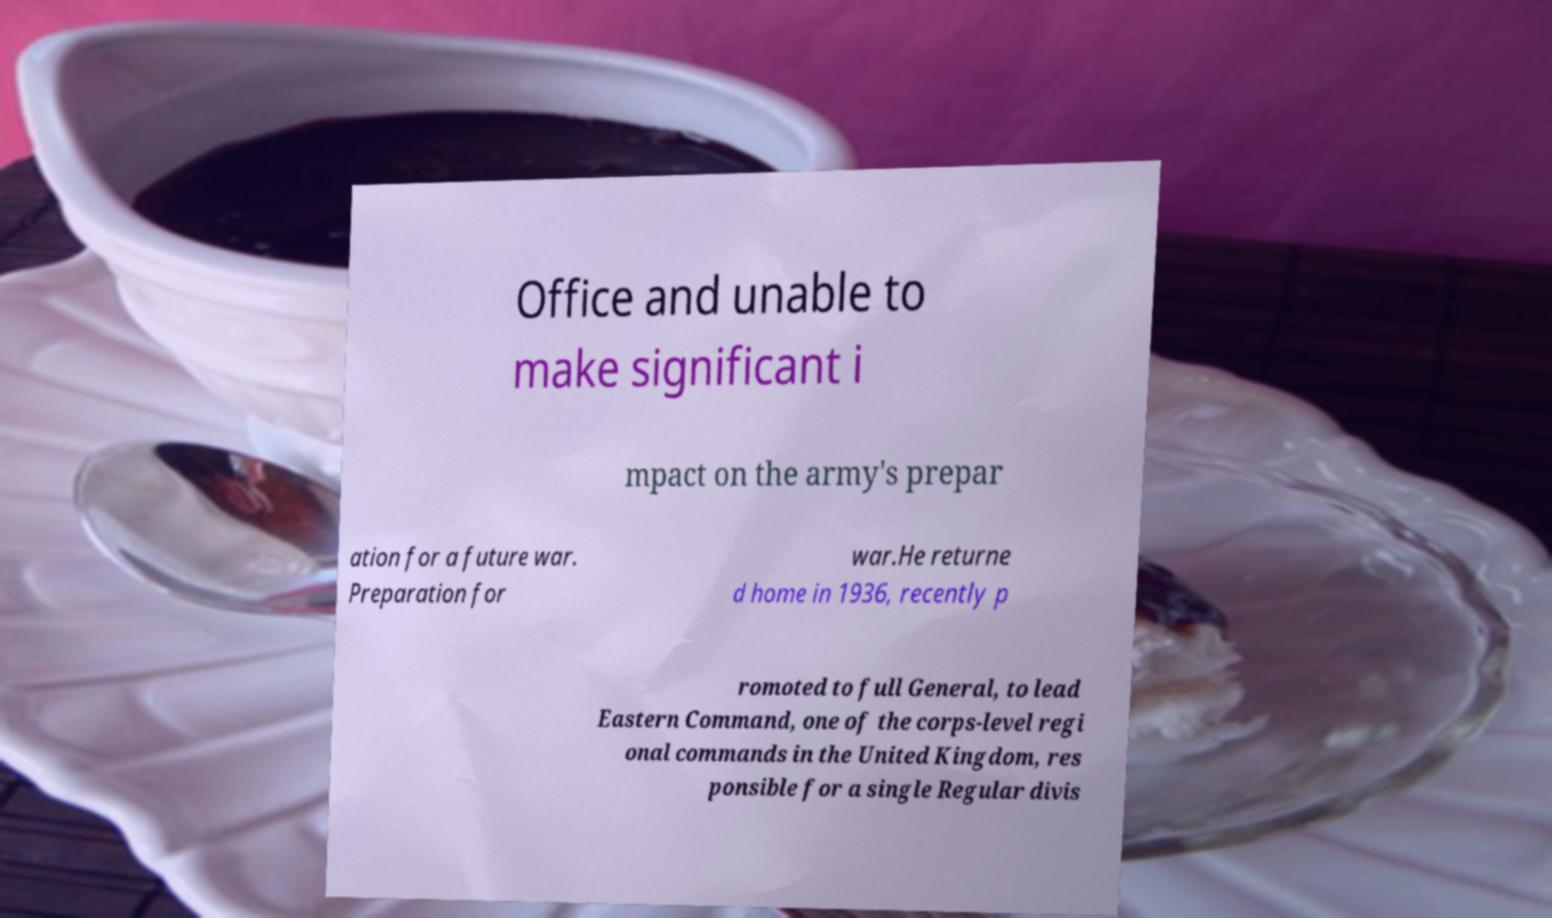Could you assist in decoding the text presented in this image and type it out clearly? Office and unable to make significant i mpact on the army's prepar ation for a future war. Preparation for war.He returne d home in 1936, recently p romoted to full General, to lead Eastern Command, one of the corps-level regi onal commands in the United Kingdom, res ponsible for a single Regular divis 